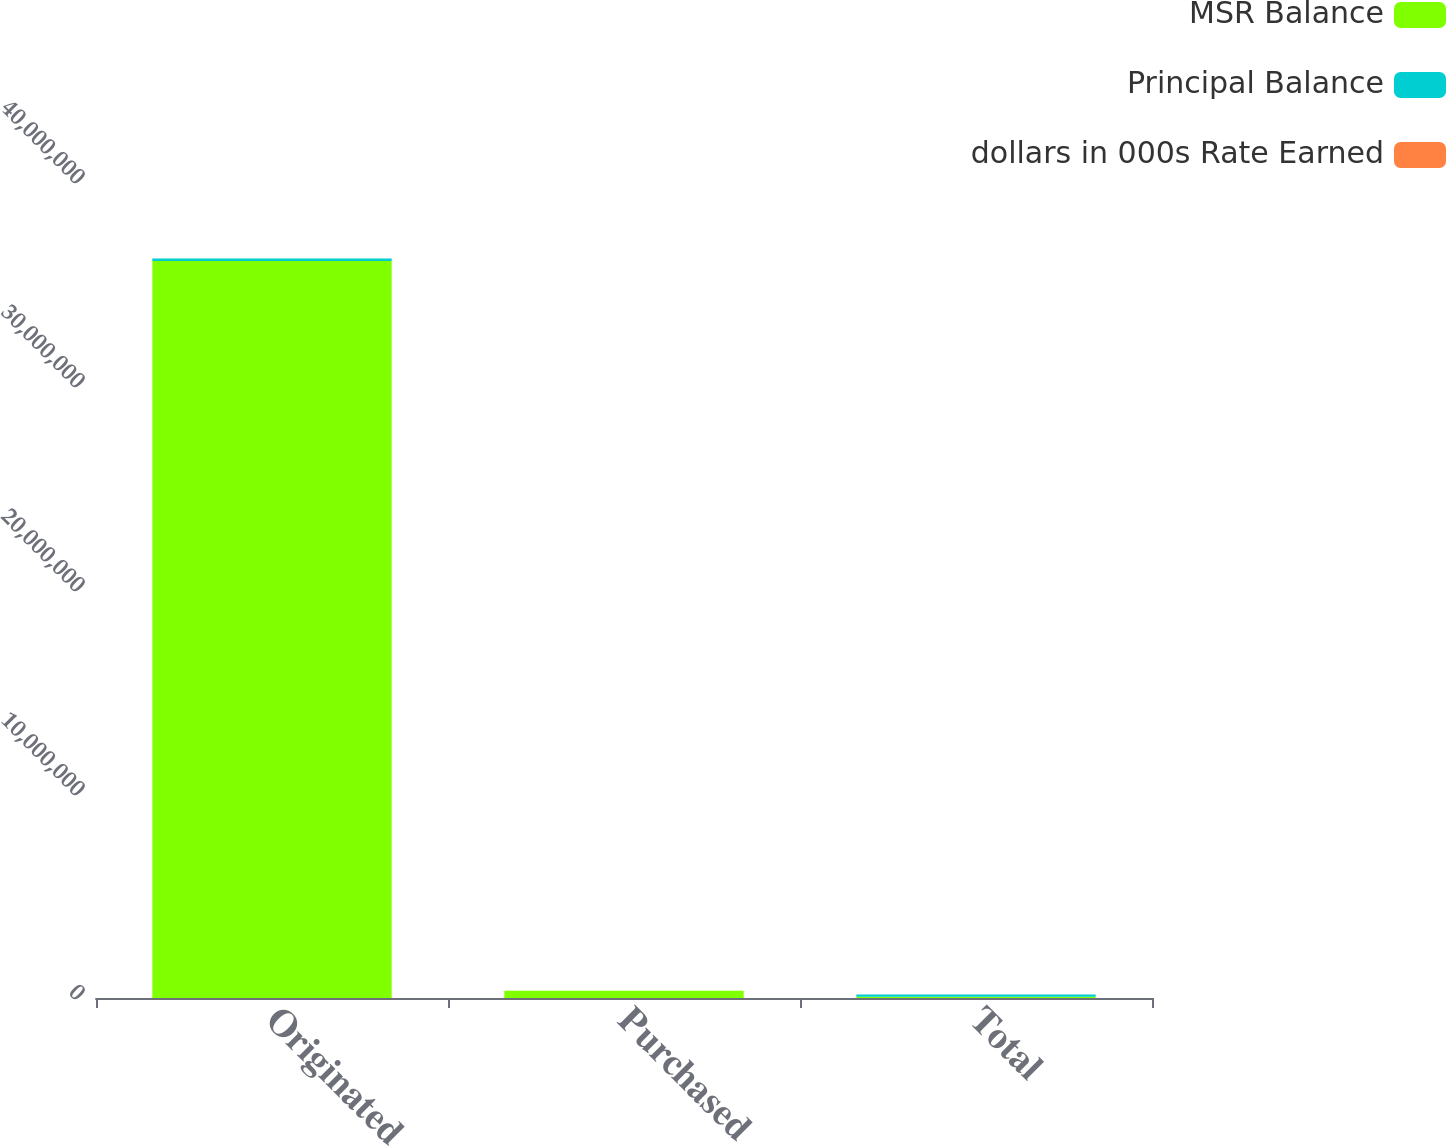Convert chart to OTSL. <chart><loc_0><loc_0><loc_500><loc_500><stacked_bar_chart><ecel><fcel>Originated<fcel>Purchased<fcel>Total<nl><fcel>MSR Balance<fcel>3.61318e+07<fcel>353576<fcel>56910.5<nl><fcel>Principal Balance<fcel>112800<fcel>1021<fcel>113821<nl><fcel>dollars in 000s Rate Earned<fcel>0.43<fcel>0.5<fcel>0.41<nl></chart> 